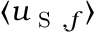Convert formula to latex. <formula><loc_0><loc_0><loc_500><loc_500>\langle u _ { S , f } \rangle</formula> 